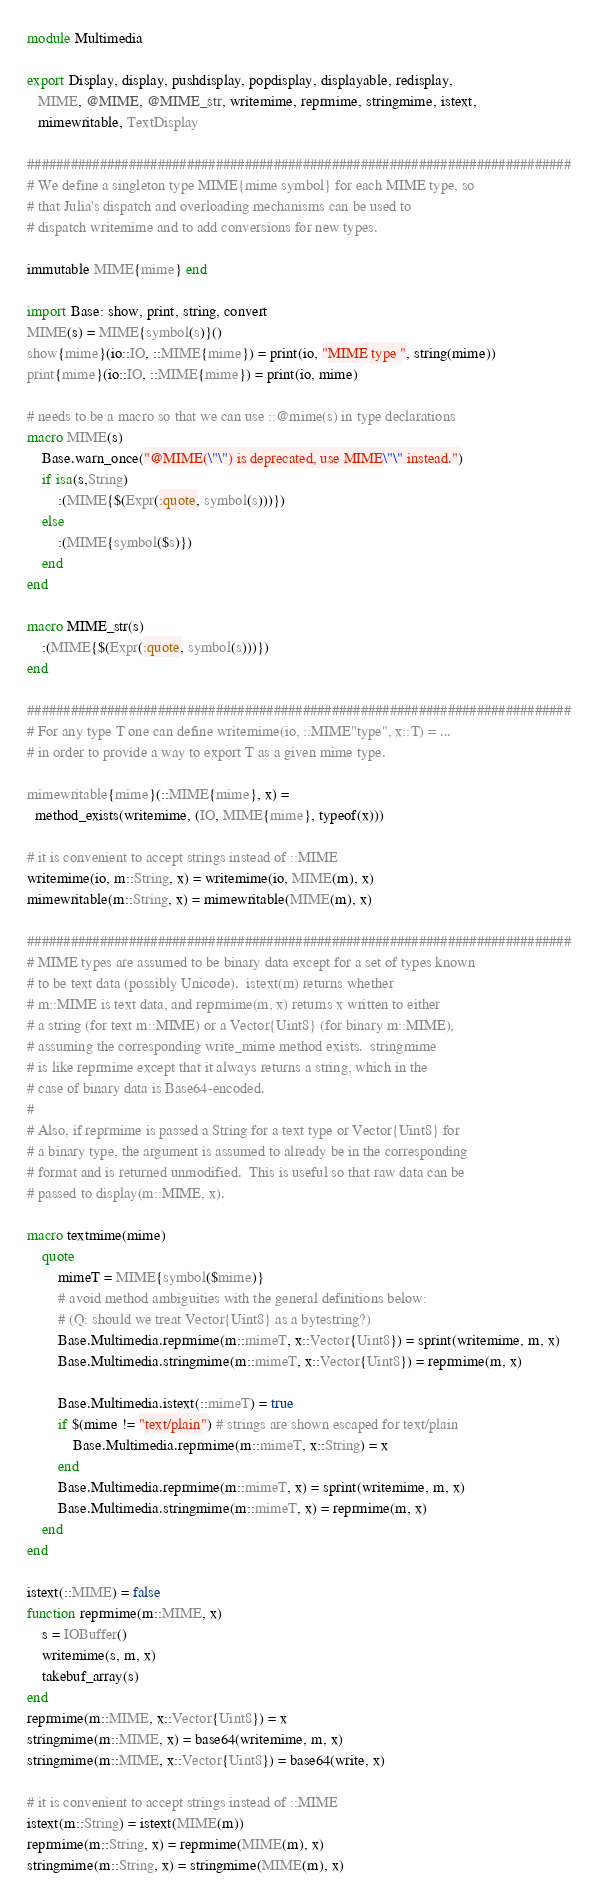Convert code to text. <code><loc_0><loc_0><loc_500><loc_500><_Julia_>module Multimedia

export Display, display, pushdisplay, popdisplay, displayable, redisplay,
   MIME, @MIME, @MIME_str, writemime, reprmime, stringmime, istext,
   mimewritable, TextDisplay

###########################################################################
# We define a singleton type MIME{mime symbol} for each MIME type, so
# that Julia's dispatch and overloading mechanisms can be used to
# dispatch writemime and to add conversions for new types.

immutable MIME{mime} end

import Base: show, print, string, convert
MIME(s) = MIME{symbol(s)}()
show{mime}(io::IO, ::MIME{mime}) = print(io, "MIME type ", string(mime))
print{mime}(io::IO, ::MIME{mime}) = print(io, mime)

# needs to be a macro so that we can use ::@mime(s) in type declarations
macro MIME(s)
    Base.warn_once("@MIME(\"\") is deprecated, use MIME\"\" instead.")
    if isa(s,String)
        :(MIME{$(Expr(:quote, symbol(s)))})
    else
        :(MIME{symbol($s)})
    end
end

macro MIME_str(s)
    :(MIME{$(Expr(:quote, symbol(s)))})
end

###########################################################################
# For any type T one can define writemime(io, ::MIME"type", x::T) = ...
# in order to provide a way to export T as a given mime type.

mimewritable{mime}(::MIME{mime}, x) =
  method_exists(writemime, (IO, MIME{mime}, typeof(x)))

# it is convenient to accept strings instead of ::MIME
writemime(io, m::String, x) = writemime(io, MIME(m), x)
mimewritable(m::String, x) = mimewritable(MIME(m), x)

###########################################################################
# MIME types are assumed to be binary data except for a set of types known
# to be text data (possibly Unicode).  istext(m) returns whether
# m::MIME is text data, and reprmime(m, x) returns x written to either
# a string (for text m::MIME) or a Vector{Uint8} (for binary m::MIME),
# assuming the corresponding write_mime method exists.  stringmime
# is like reprmime except that it always returns a string, which in the
# case of binary data is Base64-encoded.
#
# Also, if reprmime is passed a String for a text type or Vector{Uint8} for
# a binary type, the argument is assumed to already be in the corresponding
# format and is returned unmodified.  This is useful so that raw data can be
# passed to display(m::MIME, x).

macro textmime(mime)
    quote
        mimeT = MIME{symbol($mime)}
        # avoid method ambiguities with the general definitions below:
        # (Q: should we treat Vector{Uint8} as a bytestring?)
        Base.Multimedia.reprmime(m::mimeT, x::Vector{Uint8}) = sprint(writemime, m, x)
        Base.Multimedia.stringmime(m::mimeT, x::Vector{Uint8}) = reprmime(m, x)

        Base.Multimedia.istext(::mimeT) = true
        if $(mime != "text/plain") # strings are shown escaped for text/plain
            Base.Multimedia.reprmime(m::mimeT, x::String) = x
        end
        Base.Multimedia.reprmime(m::mimeT, x) = sprint(writemime, m, x)
        Base.Multimedia.stringmime(m::mimeT, x) = reprmime(m, x)
    end
end

istext(::MIME) = false
function reprmime(m::MIME, x)
    s = IOBuffer()
    writemime(s, m, x)
    takebuf_array(s)
end
reprmime(m::MIME, x::Vector{Uint8}) = x
stringmime(m::MIME, x) = base64(writemime, m, x)
stringmime(m::MIME, x::Vector{Uint8}) = base64(write, x)

# it is convenient to accept strings instead of ::MIME
istext(m::String) = istext(MIME(m))
reprmime(m::String, x) = reprmime(MIME(m), x)
stringmime(m::String, x) = stringmime(MIME(m), x)
</code> 